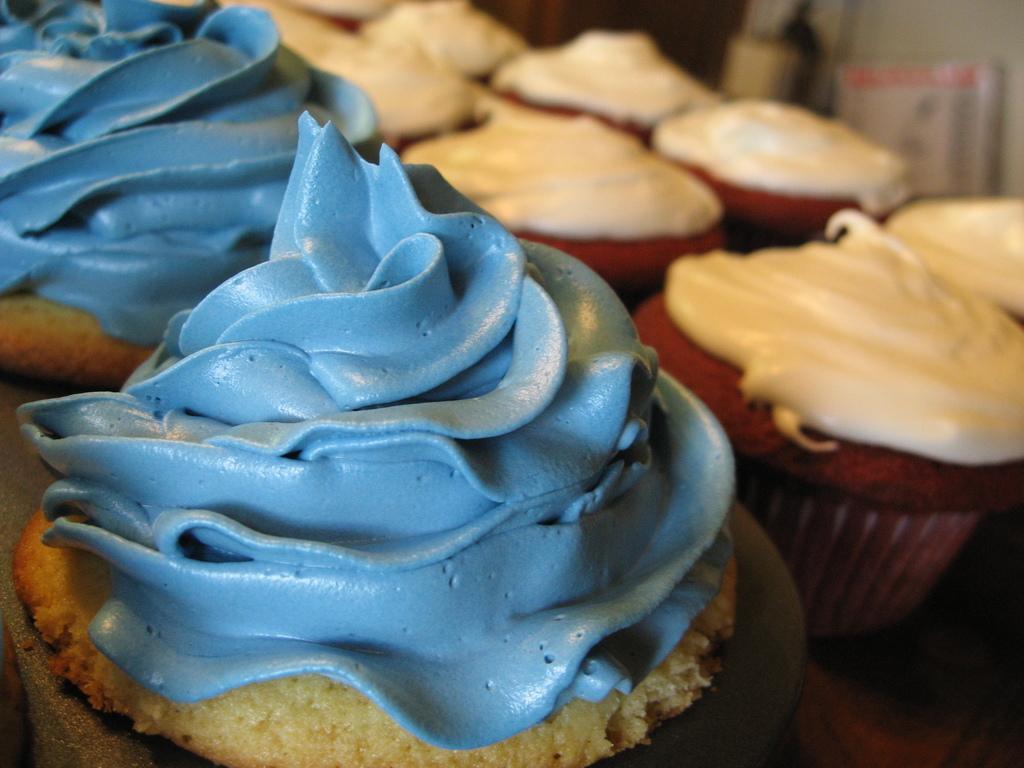Could you give a brief overview of what you see in this image? In this image, we can see few cupcakes which are placed on the table. In the background, we can also see a wall and a white color board. 